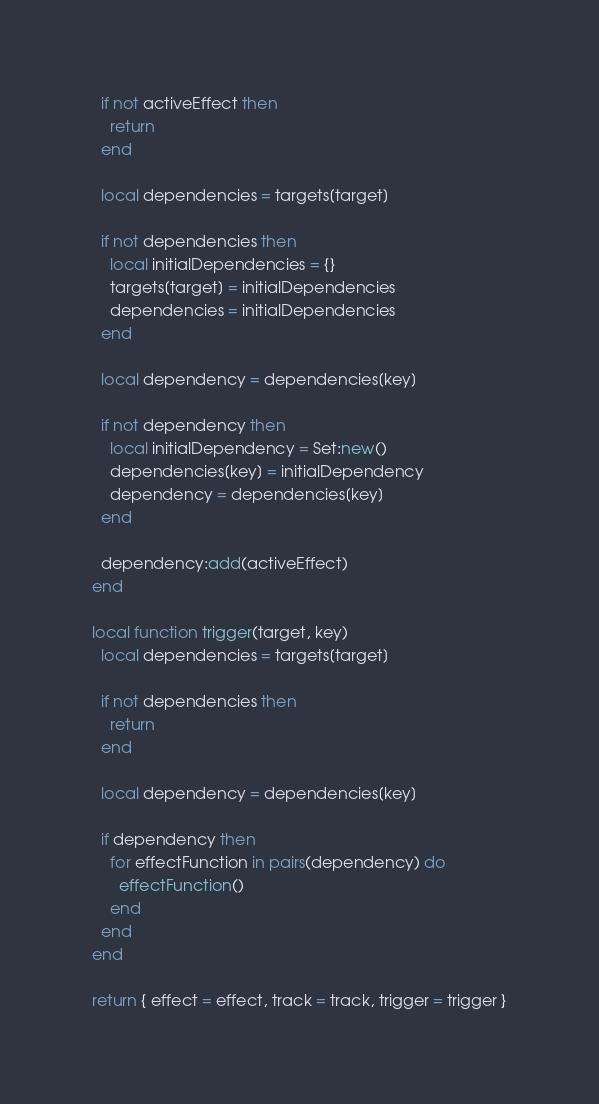Convert code to text. <code><loc_0><loc_0><loc_500><loc_500><_Lua_>  if not activeEffect then
    return
  end

  local dependencies = targets[target]

  if not dependencies then
    local initialDependencies = {}
    targets[target] = initialDependencies
    dependencies = initialDependencies
  end

  local dependency = dependencies[key]

  if not dependency then
    local initialDependency = Set:new()
    dependencies[key] = initialDependency
    dependency = dependencies[key]
  end

  dependency:add(activeEffect)
end

local function trigger(target, key)
  local dependencies = targets[target]

  if not dependencies then
    return
  end

  local dependency = dependencies[key]

  if dependency then
    for effectFunction in pairs(dependency) do
      effectFunction()
    end
  end
end

return { effect = effect, track = track, trigger = trigger }
</code> 